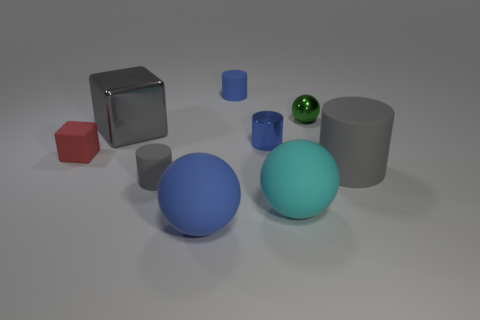Subtract 1 spheres. How many spheres are left? 2 Add 1 green shiny spheres. How many objects exist? 10 Subtract all spheres. How many objects are left? 6 Add 3 gray shiny objects. How many gray shiny objects exist? 4 Subtract 1 blue balls. How many objects are left? 8 Subtract all small metallic blocks. Subtract all rubber things. How many objects are left? 3 Add 9 small metallic cylinders. How many small metallic cylinders are left? 10 